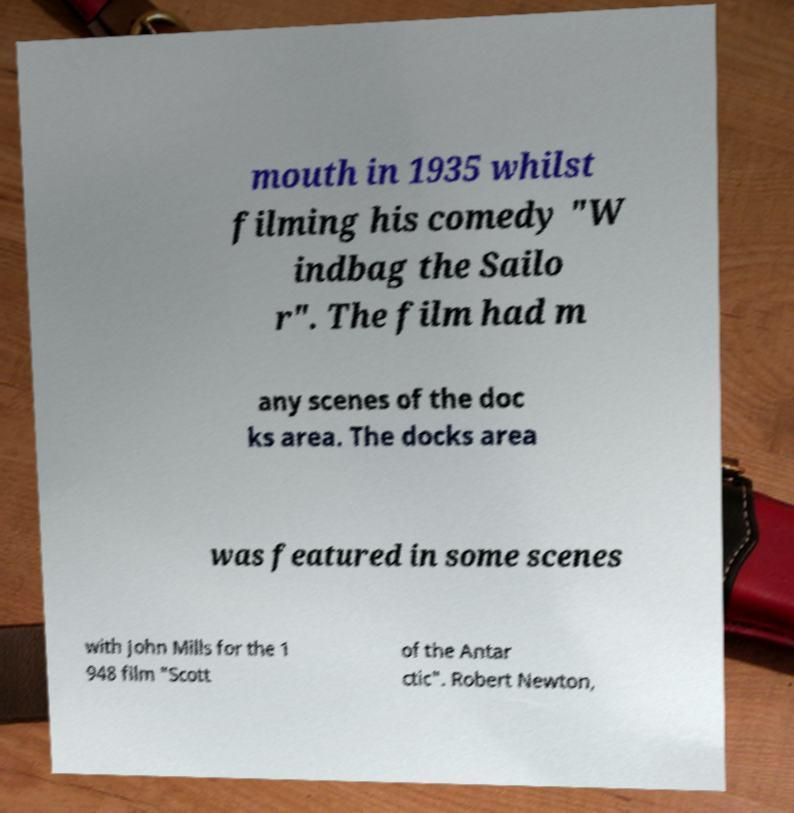Please identify and transcribe the text found in this image. mouth in 1935 whilst filming his comedy "W indbag the Sailo r". The film had m any scenes of the doc ks area. The docks area was featured in some scenes with John Mills for the 1 948 film "Scott of the Antar ctic". Robert Newton, 